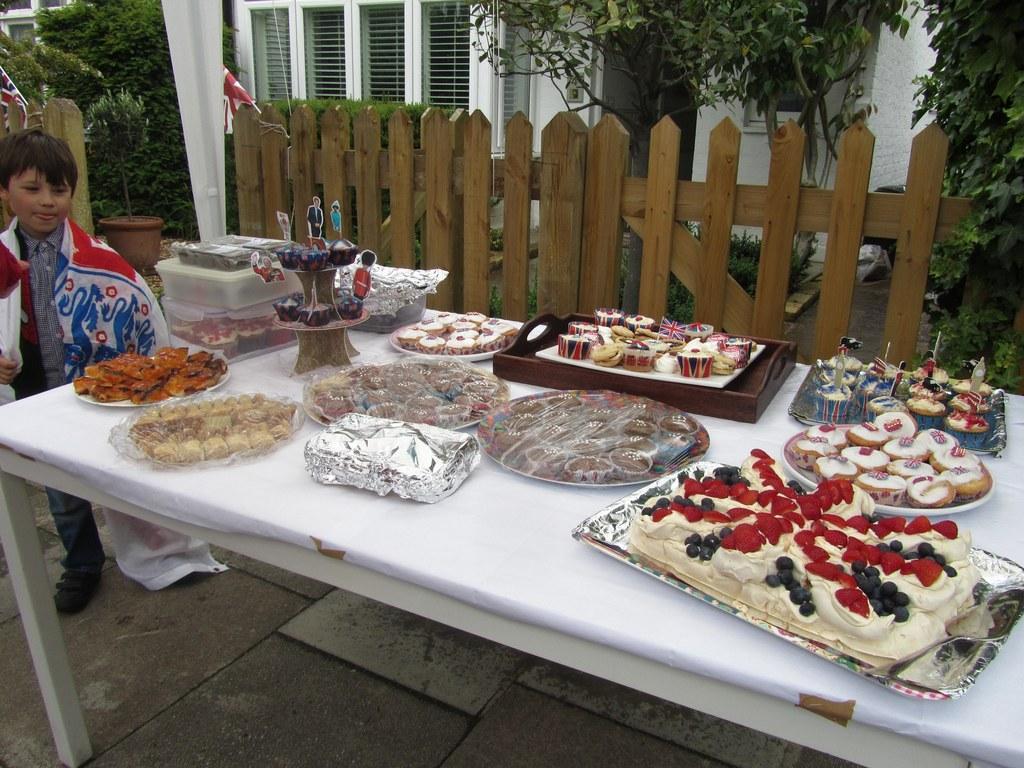Describe this image in one or two sentences. In this image i can see a boy is standing on the ground in front of a table. On the table we have few objects on it. I can also see there is a fence and few trees beside the house. 